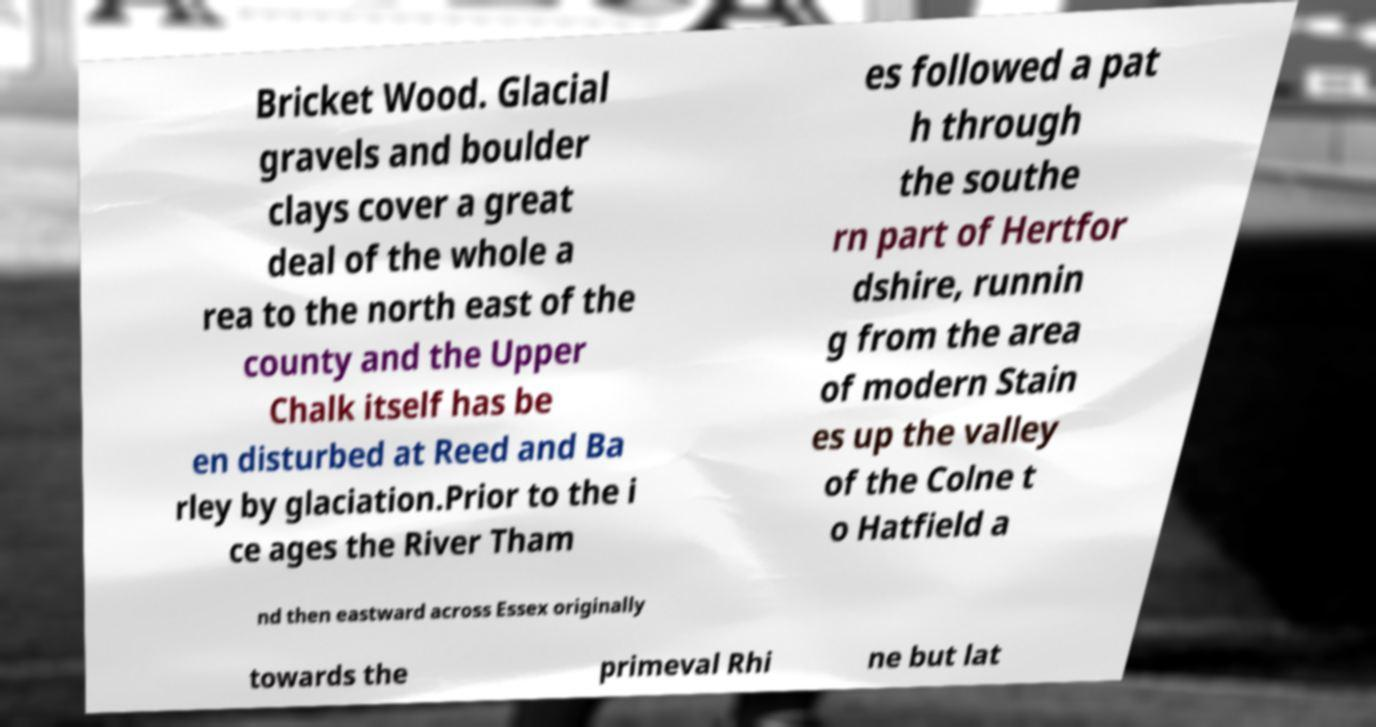Please identify and transcribe the text found in this image. Bricket Wood. Glacial gravels and boulder clays cover a great deal of the whole a rea to the north east of the county and the Upper Chalk itself has be en disturbed at Reed and Ba rley by glaciation.Prior to the i ce ages the River Tham es followed a pat h through the southe rn part of Hertfor dshire, runnin g from the area of modern Stain es up the valley of the Colne t o Hatfield a nd then eastward across Essex originally towards the primeval Rhi ne but lat 